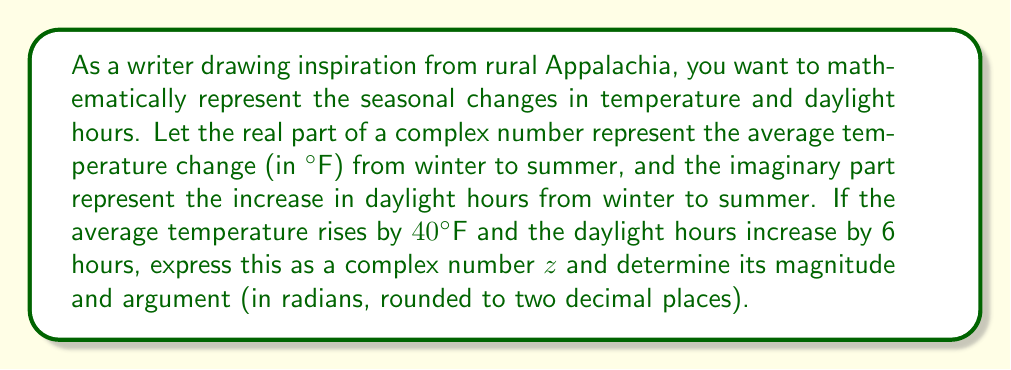Solve this math problem. Let's approach this step-by-step:

1) First, we need to express the seasonal changes as a complex number:
   $z = 40 + 6i$

2) To find the magnitude of $z$, we use the formula:
   $|z| = \sqrt{a^2 + b^2}$, where $a$ is the real part and $b$ is the imaginary part.

   $|z| = \sqrt{40^2 + 6^2} = \sqrt{1600 + 36} = \sqrt{1636} \approx 40.45$

3) To find the argument of $z$, we use the formula:
   $\arg(z) = \tan^{-1}(\frac{b}{a})$, where $a$ is the real part and $b$ is the imaginary part.

   $\arg(z) = \tan^{-1}(\frac{6}{40}) = \tan^{-1}(0.15) \approx 0.1489$ radians

4) Rounding the argument to two decimal places:
   $\arg(z) \approx 0.15$ radians

The magnitude represents the overall intensity of the seasonal change, combining both temperature and daylight changes. The argument represents the relative proportion of daylight change to temperature change.
Answer: Magnitude: $|z| \approx 40.45$
Argument: $\arg(z) \approx 0.15$ radians 